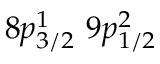<formula> <loc_0><loc_0><loc_500><loc_500>8 p _ { 3 / 2 } ^ { 1 } \, 9 p _ { 1 / 2 } ^ { 2 }</formula> 